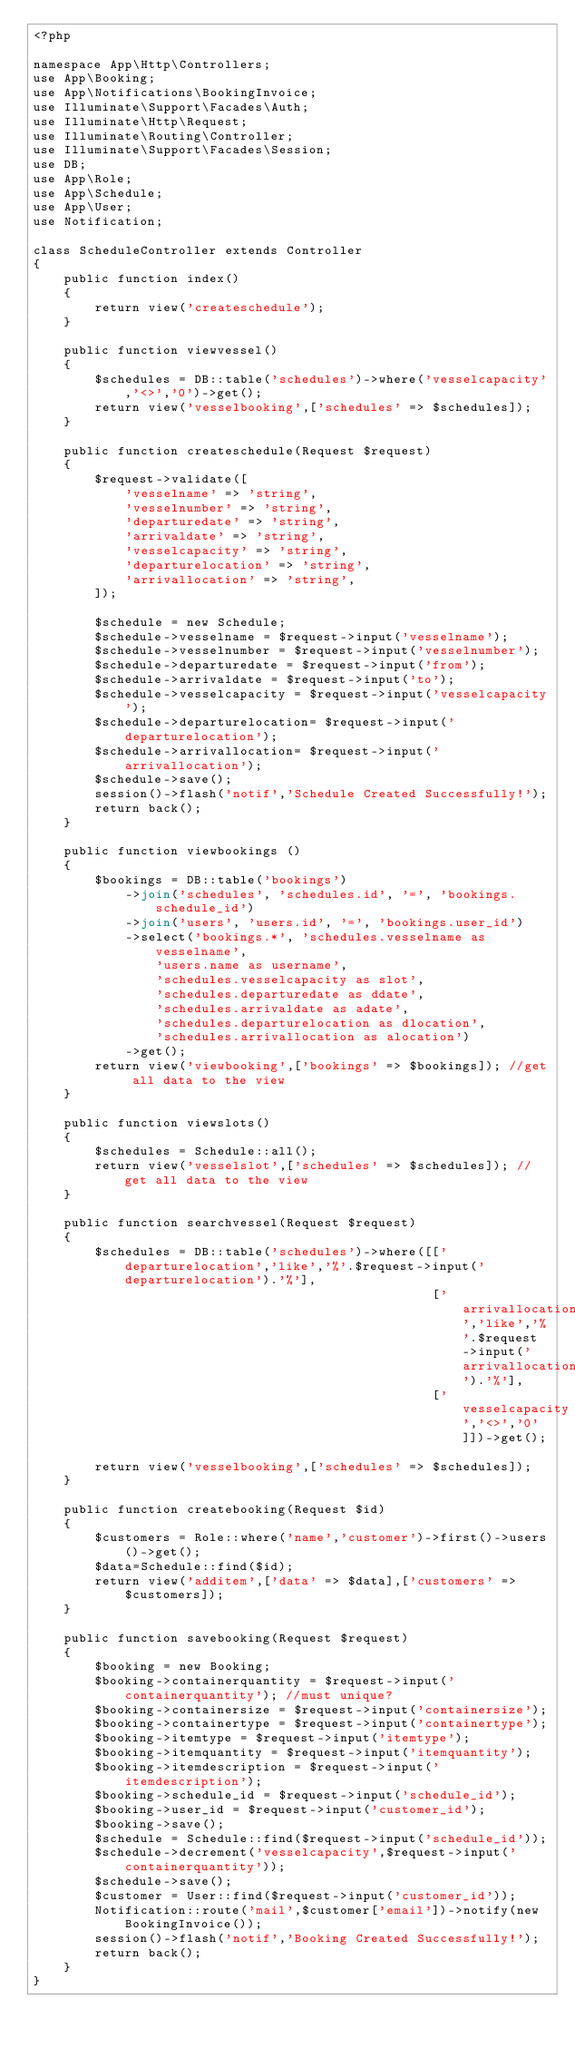Convert code to text. <code><loc_0><loc_0><loc_500><loc_500><_PHP_><?php

namespace App\Http\Controllers;
use App\Booking;
use App\Notifications\BookingInvoice;
use Illuminate\Support\Facades\Auth;
use Illuminate\Http\Request;
use Illuminate\Routing\Controller;
use Illuminate\Support\Facades\Session;
use DB;
use App\Role;
use App\Schedule;
use App\User;
use Notification;

class ScheduleController extends Controller
{
    public function index()
    {
        return view('createschedule');
    }

    public function viewvessel()
    {
        $schedules = DB::table('schedules')->where('vesselcapacity','<>','0')->get();
        return view('vesselbooking',['schedules' => $schedules]);
    }

    public function createschedule(Request $request)
    {
        $request->validate([
            'vesselname' => 'string',
            'vesselnumber' => 'string',
            'departuredate' => 'string',
            'arrivaldate' => 'string',
            'vesselcapacity' => 'string',
            'departurelocation' => 'string',
            'arrivallocation' => 'string',
        ]);

        $schedule = new Schedule;
        $schedule->vesselname = $request->input('vesselname');
        $schedule->vesselnumber = $request->input('vesselnumber');
        $schedule->departuredate = $request->input('from');
        $schedule->arrivaldate = $request->input('to');
        $schedule->vesselcapacity = $request->input('vesselcapacity');
        $schedule->departurelocation= $request->input('departurelocation');
        $schedule->arrivallocation= $request->input('arrivallocation');
        $schedule->save();
        session()->flash('notif','Schedule Created Successfully!');
        return back();
    }

    public function viewbookings ()
    {
        $bookings = DB::table('bookings')
            ->join('schedules', 'schedules.id', '=', 'bookings.schedule_id')
            ->join('users', 'users.id', '=', 'bookings.user_id')
            ->select('bookings.*', 'schedules.vesselname as vesselname',
                'users.name as username',
                'schedules.vesselcapacity as slot',
                'schedules.departuredate as ddate',
                'schedules.arrivaldate as adate',
                'schedules.departurelocation as dlocation',
                'schedules.arrivallocation as alocation')
            ->get();
        return view('viewbooking',['bookings' => $bookings]); //get all data to the view
    }

    public function viewslots()
    {
        $schedules = Schedule::all();
        return view('vesselslot',['schedules' => $schedules]); //get all data to the view
    }

    public function searchvessel(Request $request)
    {
        $schedules = DB::table('schedules')->where([['departurelocation','like','%'.$request->input('departurelocation').'%'],
                                                    ['arrivallocation','like','%'.$request->input('arrivallocation').'%'],
                                                    ['vesselcapacity','<>','0']])->get();

        return view('vesselbooking',['schedules' => $schedules]);
    }

    public function createbooking(Request $id)
    {
        $customers = Role::where('name','customer')->first()->users()->get();
        $data=Schedule::find($id);
        return view('additem',['data' => $data],['customers' =>$customers]);
    }

    public function savebooking(Request $request)
    {
        $booking = new Booking;
        $booking->containerquantity = $request->input('containerquantity'); //must unique?
        $booking->containersize = $request->input('containersize');
        $booking->containertype = $request->input('containertype');
        $booking->itemtype = $request->input('itemtype');
        $booking->itemquantity = $request->input('itemquantity');
        $booking->itemdescription = $request->input('itemdescription');
        $booking->schedule_id = $request->input('schedule_id');
        $booking->user_id = $request->input('customer_id');
        $booking->save();
        $schedule = Schedule::find($request->input('schedule_id'));
        $schedule->decrement('vesselcapacity',$request->input('containerquantity'));
        $schedule->save();
        $customer = User::find($request->input('customer_id'));
        Notification::route('mail',$customer['email'])->notify(new BookingInvoice());
        session()->flash('notif','Booking Created Successfully!');
        return back();
    }
}
</code> 